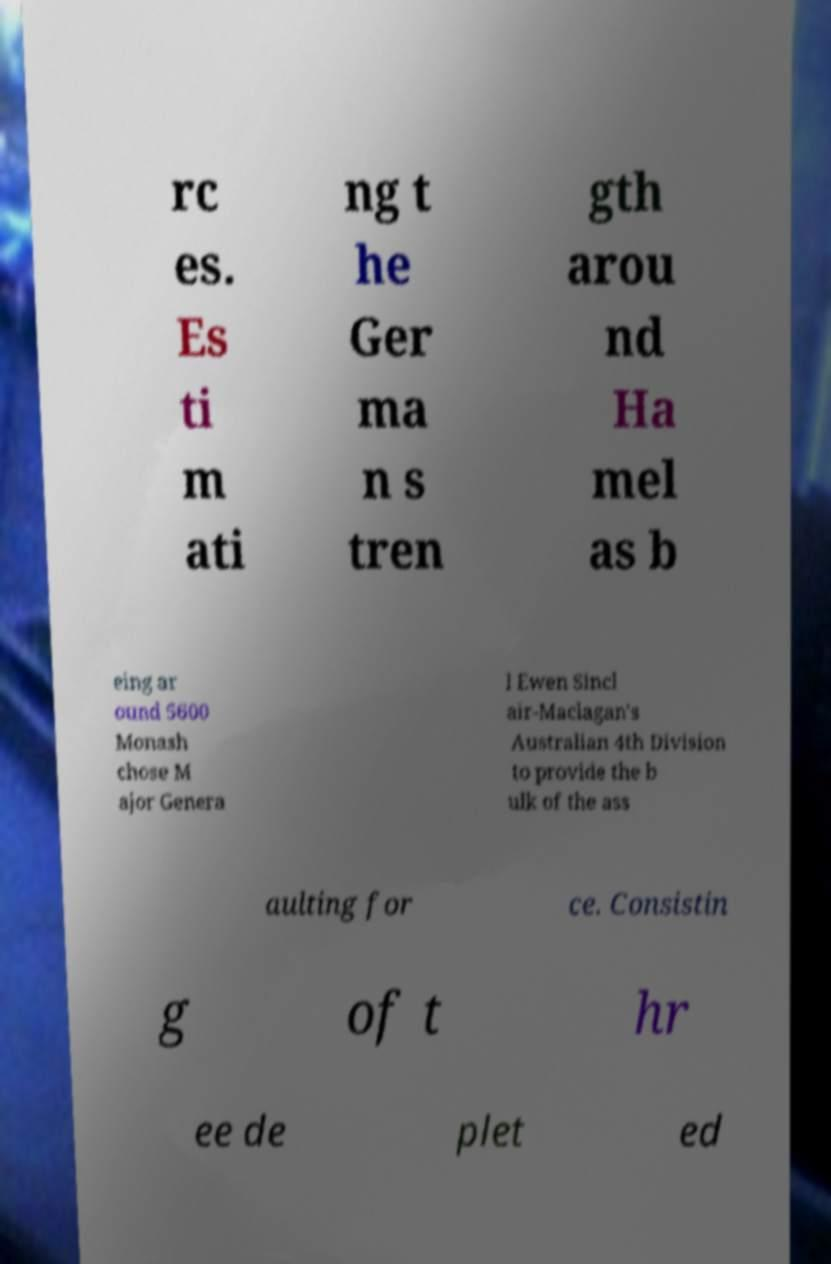Please identify and transcribe the text found in this image. rc es. Es ti m ati ng t he Ger ma n s tren gth arou nd Ha mel as b eing ar ound 5600 Monash chose M ajor Genera l Ewen Sincl air-Maclagan's Australian 4th Division to provide the b ulk of the ass aulting for ce. Consistin g of t hr ee de plet ed 